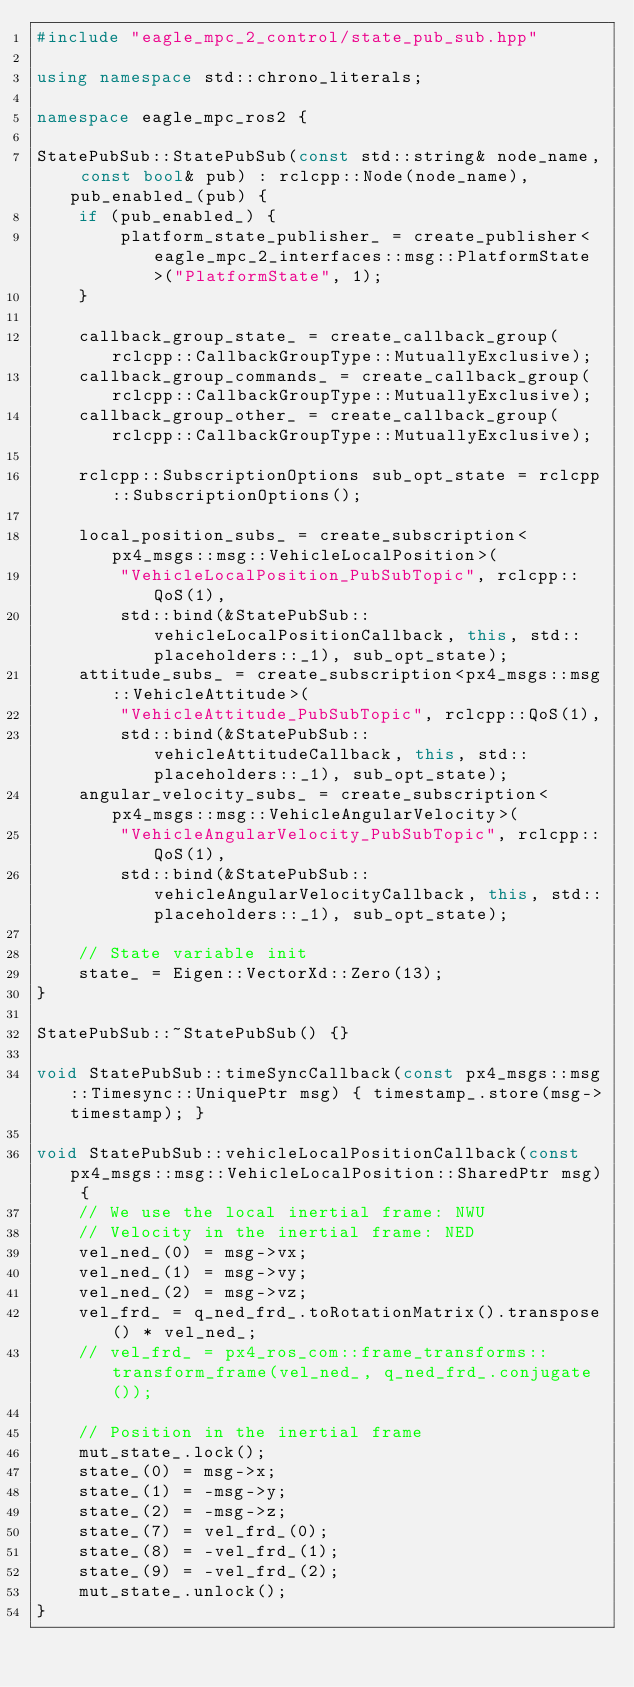<code> <loc_0><loc_0><loc_500><loc_500><_C++_>#include "eagle_mpc_2_control/state_pub_sub.hpp"

using namespace std::chrono_literals;

namespace eagle_mpc_ros2 {

StatePubSub::StatePubSub(const std::string& node_name, const bool& pub) : rclcpp::Node(node_name), pub_enabled_(pub) {
    if (pub_enabled_) {
        platform_state_publisher_ = create_publisher<eagle_mpc_2_interfaces::msg::PlatformState>("PlatformState", 1);
    }

    callback_group_state_ = create_callback_group(rclcpp::CallbackGroupType::MutuallyExclusive);
    callback_group_commands_ = create_callback_group(rclcpp::CallbackGroupType::MutuallyExclusive);
    callback_group_other_ = create_callback_group(rclcpp::CallbackGroupType::MutuallyExclusive);

    rclcpp::SubscriptionOptions sub_opt_state = rclcpp::SubscriptionOptions();

    local_position_subs_ = create_subscription<px4_msgs::msg::VehicleLocalPosition>(
        "VehicleLocalPosition_PubSubTopic", rclcpp::QoS(1),
        std::bind(&StatePubSub::vehicleLocalPositionCallback, this, std::placeholders::_1), sub_opt_state);
    attitude_subs_ = create_subscription<px4_msgs::msg::VehicleAttitude>(
        "VehicleAttitude_PubSubTopic", rclcpp::QoS(1),
        std::bind(&StatePubSub::vehicleAttitudeCallback, this, std::placeholders::_1), sub_opt_state);
    angular_velocity_subs_ = create_subscription<px4_msgs::msg::VehicleAngularVelocity>(
        "VehicleAngularVelocity_PubSubTopic", rclcpp::QoS(1),
        std::bind(&StatePubSub::vehicleAngularVelocityCallback, this, std::placeholders::_1), sub_opt_state);

    // State variable init
    state_ = Eigen::VectorXd::Zero(13);
}

StatePubSub::~StatePubSub() {}

void StatePubSub::timeSyncCallback(const px4_msgs::msg::Timesync::UniquePtr msg) { timestamp_.store(msg->timestamp); }

void StatePubSub::vehicleLocalPositionCallback(const px4_msgs::msg::VehicleLocalPosition::SharedPtr msg) {
    // We use the local inertial frame: NWU
    // Velocity in the inertial frame: NED
    vel_ned_(0) = msg->vx;
    vel_ned_(1) = msg->vy;
    vel_ned_(2) = msg->vz;
    vel_frd_ = q_ned_frd_.toRotationMatrix().transpose() * vel_ned_;
    // vel_frd_ = px4_ros_com::frame_transforms::transform_frame(vel_ned_, q_ned_frd_.conjugate());

    // Position in the inertial frame
    mut_state_.lock();
    state_(0) = msg->x;
    state_(1) = -msg->y;
    state_(2) = -msg->z;
    state_(7) = vel_frd_(0);
    state_(8) = -vel_frd_(1);
    state_(9) = -vel_frd_(2);
    mut_state_.unlock();
}
</code> 